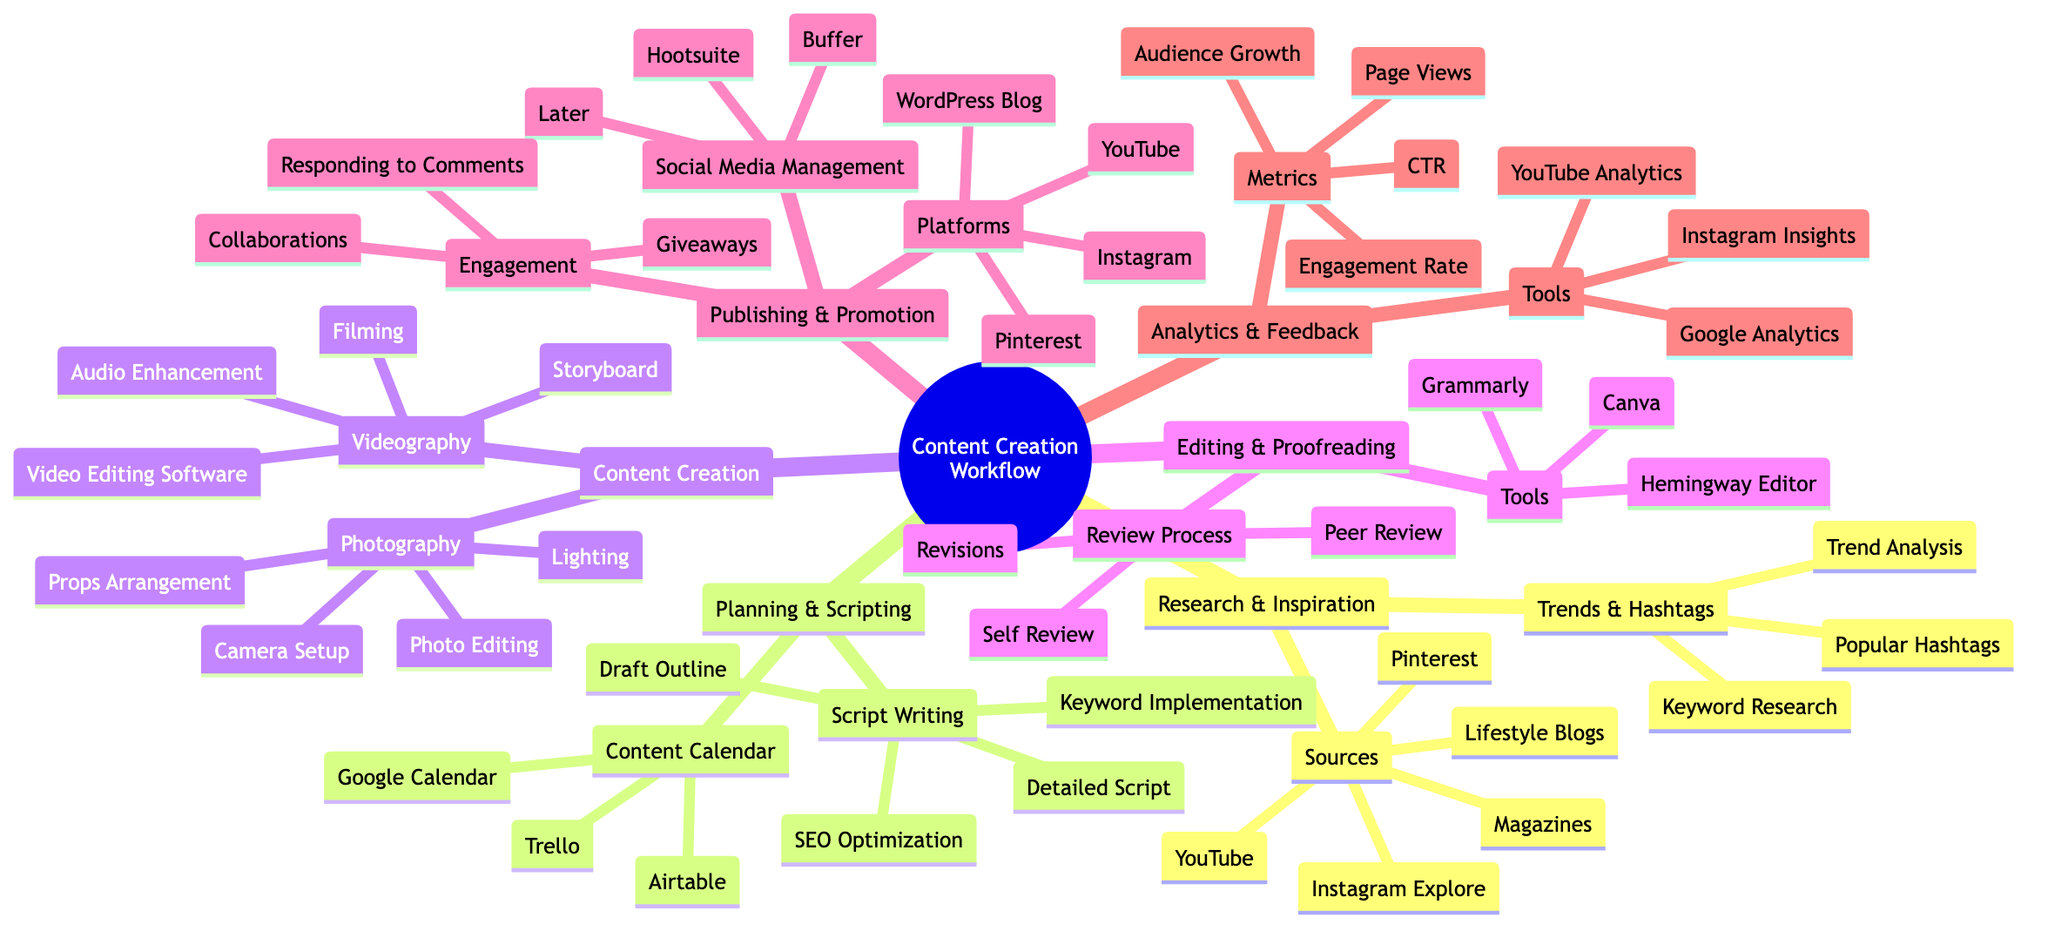What are three sources for Research and Inspiration? The node "Sources" under "Research and Inspiration" lists five specific options, among which three are Pinterest, Instagram Explore, and Lifestyle Blogs.
Answer: Pinterest, Instagram Explore, Lifestyle Blogs How many tools are listed in the Editing and Proofreading section? Under the "Editing and Proofreading" section, there is a node labeled "Tools" which lists three specific tools: Grammarly, Hemingway Editor, and Canva, making a total of three tools listed.
Answer: 3 Which content creation method includes Photo Editing? Looking at the "Content Creation" section, the "Photography" subsections contain "Photo Editing" as a related method. This indicates that Photo Editing is specifically part of the Photography method of content creation.
Answer: Photography What is one way to analyze trends in Research and Inspiration? Under the "Trends and Hashtags" node in the "Research and Inspiration" section, one listed method is "Trend Analysis," which is stated as a method to analyze trends. Hence, it answers the question about analyzing trends.
Answer: Trend Analysis Which platform is NOT listed in the Publishing and Promotion section? By reviewing the "Platforms" node within the "Publishing and Promotion" section, it identifies specific platforms: WordPress Blog, Instagram, YouTube, and Pinterest. Therefore, any platform outside these four will be the answer, for instance, Facebook is one such platform not listed.
Answer: Facebook What is a component of the Content Creation workflow that involves script writing? The "Planning and Scripting" section comprises a node "Script Writing," which includes elements like Draft Outline, Detailed Script, SEO Optimization, and Keyword Implementation, indicating these all relate to script writing activities.
Answer: Script Writing Which tool is utilized for SEO Optimization in Planning and Scripting? The node "Script Writing" under the "Planning and Scripting" section includes "SEO Optimization" as one of its direct components, indicating its direct inclusion in the script writing process.
Answer: SEO Optimization What metric is used to assess Audience Growth in Analytics and Feedback? Under the "Metrics" node in the "Analytics and Feedback" section, "Audience Growth" is explicitly listed as one of the metrics for measuring feedback, indicating its relevance to the query about audience assessment.
Answer: Audience Growth 